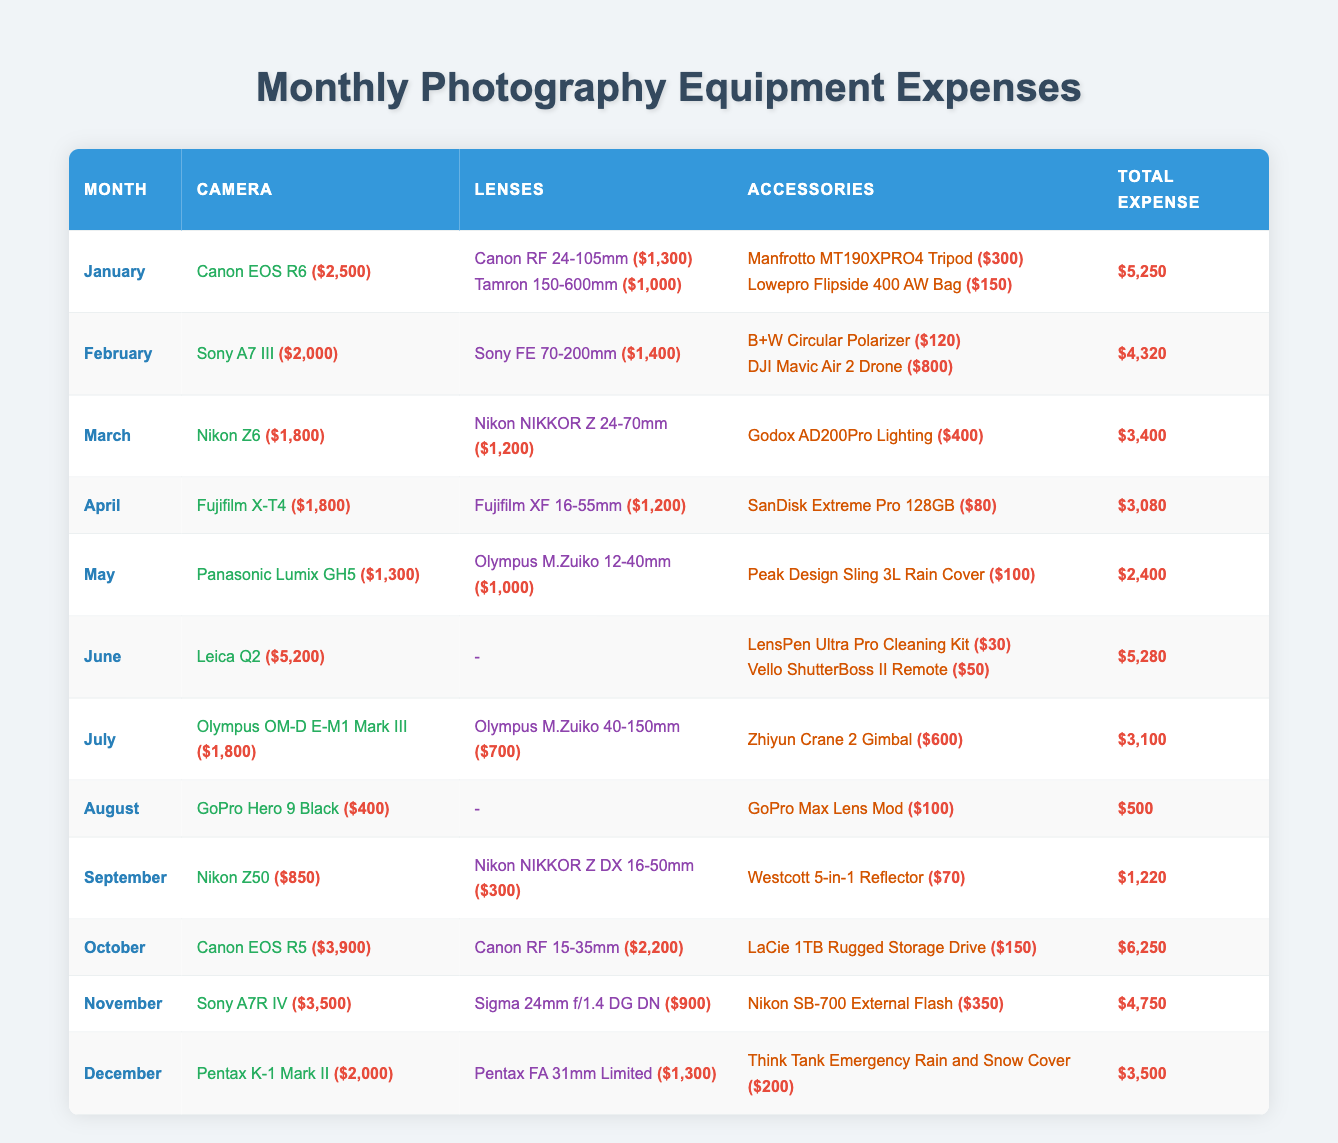What was the total expense for June? In June, the Leica Q2 camera expense was $5,200, with accessories costing $30 and $50. Thus, the total expense for June is $5,200 + $30 + $50 = $5,280
Answer: $5,280 Which camera had the highest expense in October? In October, the Canon EOS R5 camera was listed with an expense of $3,900, which is the highest camera expense for that month
Answer: Canon EOS R5 How much did I spend on lenses in February? In February, the only lens listed is the Sony FE 70-200mm with an expense of $1,400. Therefore, my total lens expense for that month is simply $1,400
Answer: $1,400 What was the total expense for the entire year? To find the total annual expense, we sum the total expenses from each month. The expenses are: January $5,250, February $4,320, March $3,400, April $3,080, May $2,400, June $5,280, July $3,100, August $500, September $1,220, October $6,250, November $4,750, December $3,500. Summing these gives us: 5,250 + 4,320 + 3,400 + 3,080 + 2,400 + 5,280 + 3,100 + 500 + 1,220 + 6,250 + 4,750 + 3,500 = $43,250
Answer: $43,250 Did I spend more on lenses or accessories in March? In March, the total expense for lenses (Nikon NIKKOR Z 24-70mm at $1,200) is $1,200, while the total for accessories (Godox AD200Pro Lighting at $400) is $400. Since $1,200 > $400, I spend more on lenses
Answer: Yes Which month had the lowest total expense, and what was it? Reviewing the monthly totals, August had an expense of $500, which is lower than any other month. Therefore, August is the month with the lowest total expense
Answer: August, $500 How much did I spend on accessories in November compared to December? In November, the accessory (Nikon SB-700 External Flash) cost $350. In December, the accessory (Think Tank Emergency Rain and Snow Cover) cost $200. Therefore, in November, I spent $350 - $200 = $150 more than in December on accessories
Answer: $150 What is the average expense on cameras for the year? The total camera expenses are calculated by summing each month's camera expense: January $2,500, February $2,000, March $1,800, April $1,800, May $1,300, June $5,200, July $1,800, August $400, September $850, October $3,900, November $3,500, December $2,000. Adding these amounts gives $2,500 + 2,000 + 1,800 + 1,800 + 1,300 + 5,200 + 1,800 + 400 + 850 + 3,900 + 3,500 + 2,000 = $27,050. There are 12 months, so the average is $27,050 / 12 = $2,254.17
Answer: $2,254.17 Was the total expense in July greater than in September? July total expense was $3,100, and September total expense was $1,220. Since $3,100 > $1,220, it means July has a greater total expense
Answer: Yes Which lens was the most expensive throughout the year? The most expensive lens listed is the Canon RF 15-35mm from October, which costs $2,200. No other lens exceeds this price
Answer: Canon RF 15-35mm, $2,200 